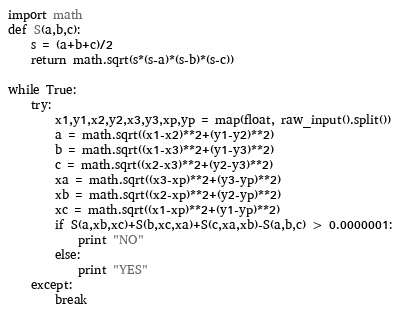Convert code to text. <code><loc_0><loc_0><loc_500><loc_500><_Python_>import math
def S(a,b,c):
	s = (a+b+c)/2
	return math.sqrt(s*(s-a)*(s-b)*(s-c))
	
while True:
	try:
		x1,y1,x2,y2,x3,y3,xp,yp = map(float, raw_input().split())
		a = math.sqrt((x1-x2)**2+(y1-y2)**2)
		b = math.sqrt((x1-x3)**2+(y1-y3)**2)
		c = math.sqrt((x2-x3)**2+(y2-y3)**2)
		xa = math.sqrt((x3-xp)**2+(y3-yp)**2)
		xb = math.sqrt((x2-xp)**2+(y2-yp)**2)
		xc = math.sqrt((x1-xp)**2+(y1-yp)**2)
		if S(a,xb,xc)+S(b,xc,xa)+S(c,xa,xb)-S(a,b,c) > 0.0000001:
			print "NO"
		else:
			print "YES"
	except:
		break</code> 